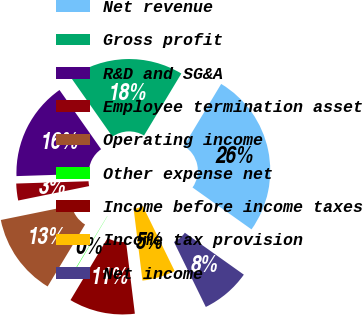<chart> <loc_0><loc_0><loc_500><loc_500><pie_chart><fcel>Net revenue<fcel>Gross profit<fcel>R&D and SG&A<fcel>Employee termination asset<fcel>Operating income<fcel>Other expense net<fcel>Income before income taxes<fcel>Income tax provision<fcel>Net income<nl><fcel>26.21%<fcel>18.37%<fcel>15.76%<fcel>2.69%<fcel>13.14%<fcel>0.08%<fcel>10.53%<fcel>5.3%<fcel>7.92%<nl></chart> 